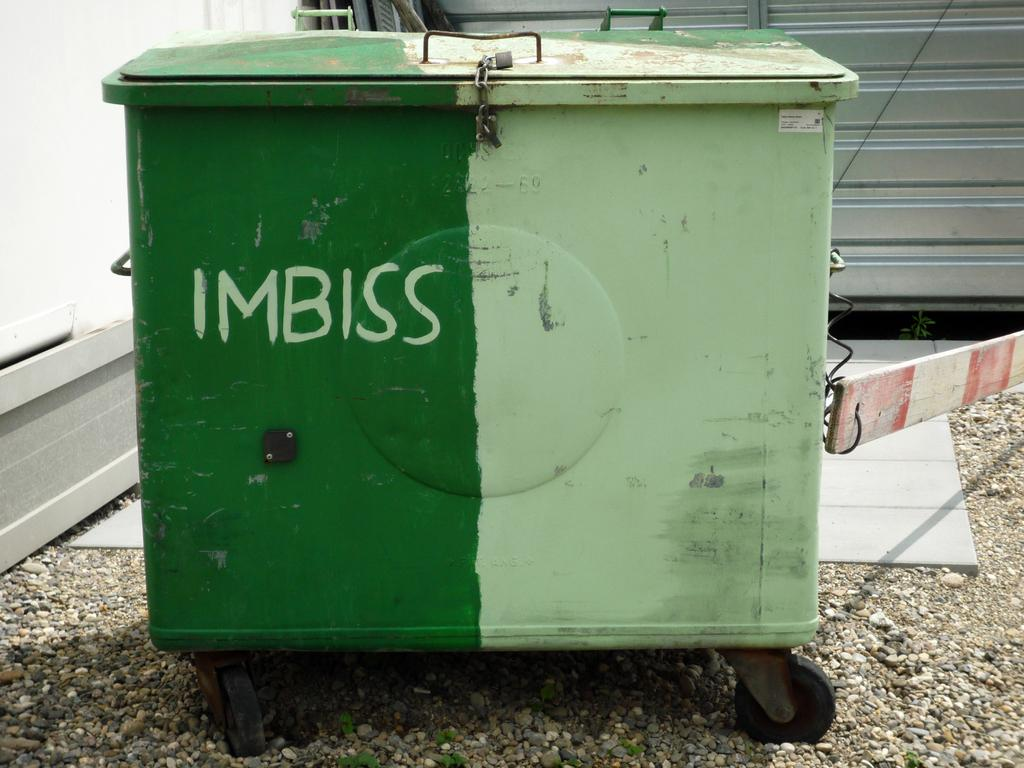What object is present in the image that has a box shape? There is a box in the image. What can be found on the surface of the box? There is text on the box. What feature of the box allows it to be easily moved? The box has wheels. What type of architectural feature can be seen at the back of the image? There is a railing at the back of the image. What type of natural element is present at the bottom of the image? There are stones at the bottom of the image. How many cattle are grazing near the box in the image? There are no cattle present in the image. What type of coin is depicted on the box in the image? There is no coin, specifically a quarter, depicted on the box in the image. 